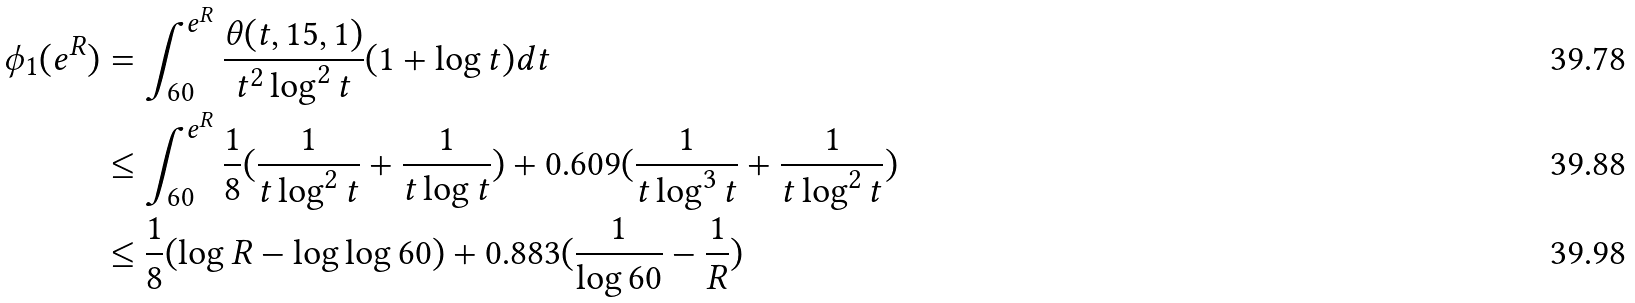Convert formula to latex. <formula><loc_0><loc_0><loc_500><loc_500>\phi _ { 1 } ( e ^ { R } ) & = \int _ { 6 0 } ^ { e ^ { R } } \frac { \theta ( t , 1 5 , 1 ) } { t ^ { 2 } \log ^ { 2 } { t } } ( 1 + \log { t } ) d t \\ & \leq \int _ { 6 0 } ^ { e ^ { R } } \frac { 1 } { 8 } ( \frac { 1 } { t \log ^ { 2 } { t } } + \frac { 1 } { t \log { t } } ) + 0 . 6 0 9 ( \frac { 1 } { t \log ^ { 3 } { t } } + \frac { 1 } { t \log ^ { 2 } { t } } ) \\ & \leq \frac { 1 } { 8 } ( \log { R } - \log \log { 6 0 } ) + 0 . 8 8 3 ( \frac { 1 } { \log { 6 0 } } - \frac { 1 } { R } )</formula> 